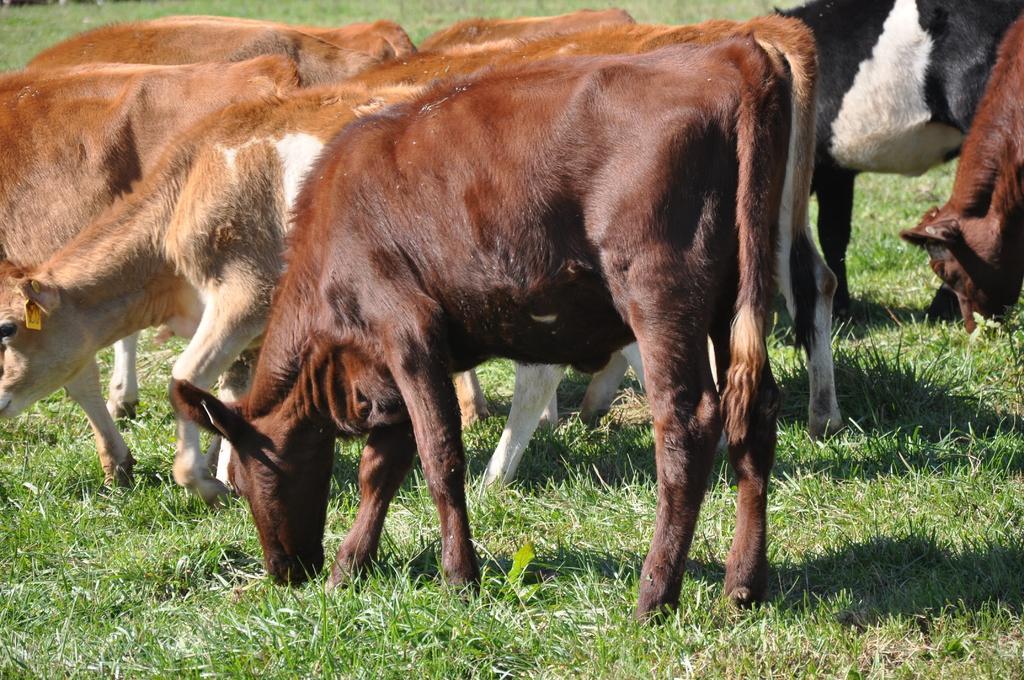Could you give a brief overview of what you see in this image? In this image we can see a group of animals eating grass on the grassy land. 